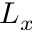Convert formula to latex. <formula><loc_0><loc_0><loc_500><loc_500>L _ { x }</formula> 